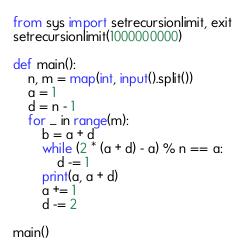Convert code to text. <code><loc_0><loc_0><loc_500><loc_500><_Python_>from sys import setrecursionlimit, exit
setrecursionlimit(1000000000)

def main():
    n, m = map(int, input().split())
    a = 1
    d = n - 1
    for _ in range(m):
        b = a + d
        while (2 * (a + d) - a) % n == a:
            d -= 1
        print(a, a + d)
        a += 1
        d -= 2

main()</code> 